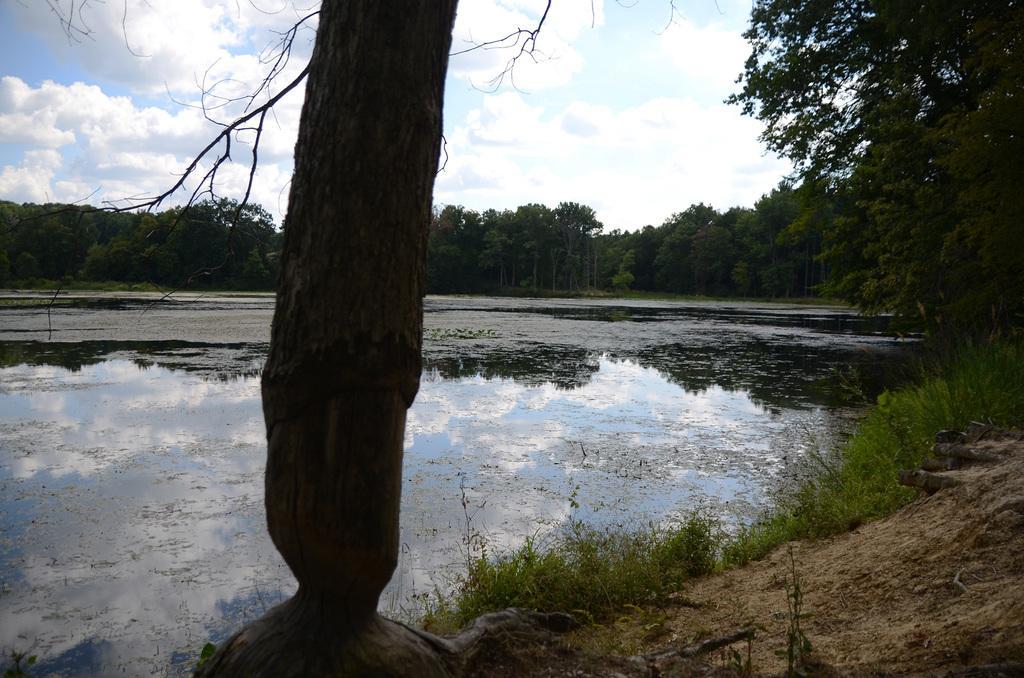In one or two sentences, can you explain what this image depicts? In this picture, we can see the ground, plants, water, we can see trees, and the sky with clouds. 